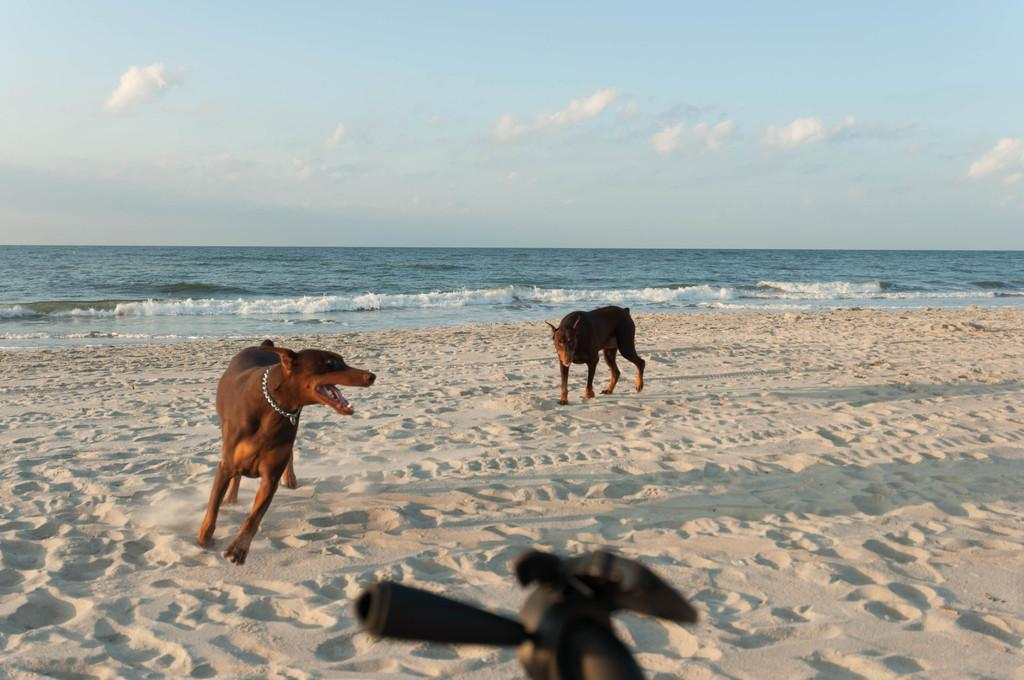What type of location is depicted in the image? There is a beach in the image. What natural feature is visible near the beach? There is an ocean in the image. Are there any animals present on the beach? Yes, there are two dogs on the beach. What is the color of the sky in the image? The sky is blue with clouds. What type of hook can be seen in the image? There is no hook present in the image. What flavor of pie is being served on the beach? There is no pie present in the image. 